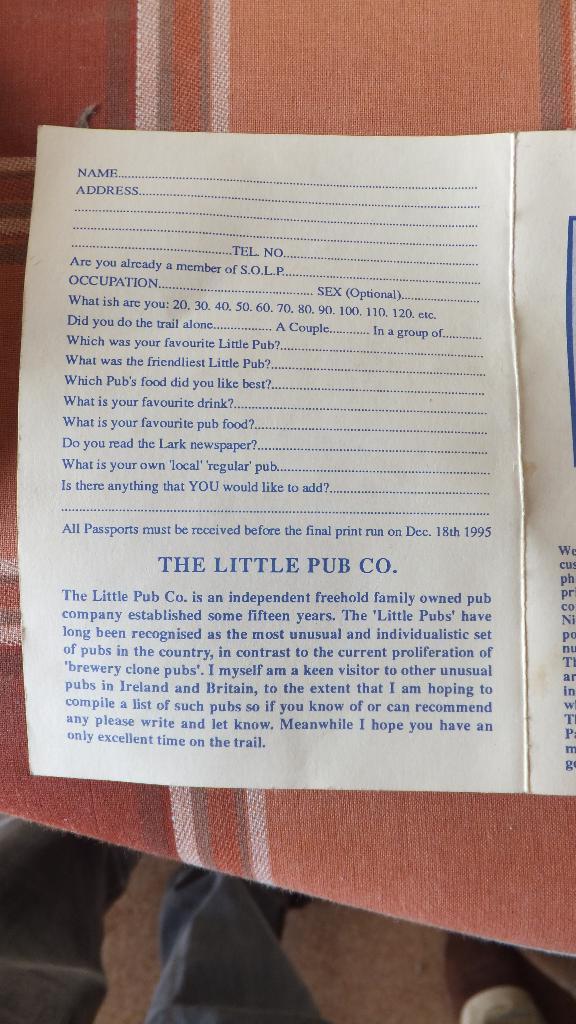Describe this image in one or two sentences. In this image we can see papers with text. And the papers are on a cloth. At the bottom we can see legs of a person. 